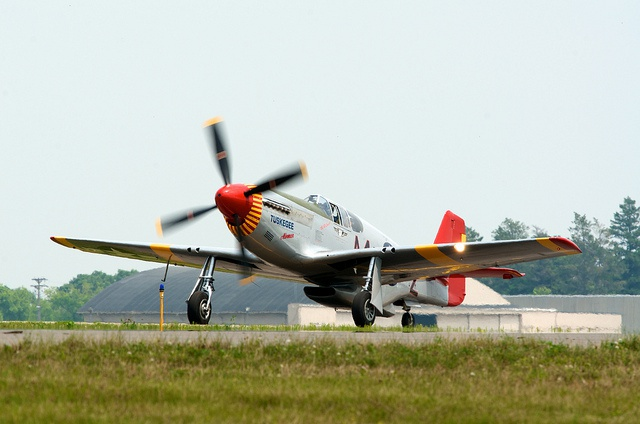Describe the objects in this image and their specific colors. I can see a airplane in white, black, gray, lightgray, and darkgray tones in this image. 